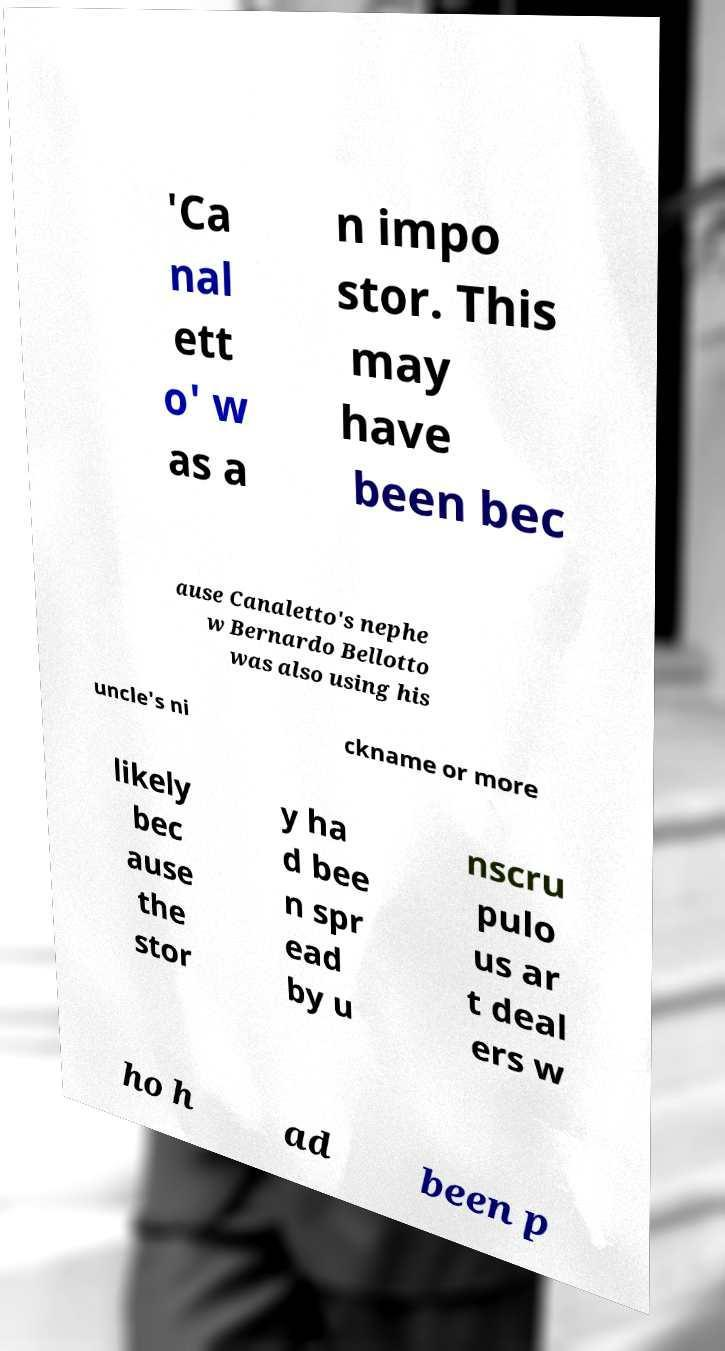For documentation purposes, I need the text within this image transcribed. Could you provide that? 'Ca nal ett o' w as a n impo stor. This may have been bec ause Canaletto's nephe w Bernardo Bellotto was also using his uncle's ni ckname or more likely bec ause the stor y ha d bee n spr ead by u nscru pulo us ar t deal ers w ho h ad been p 